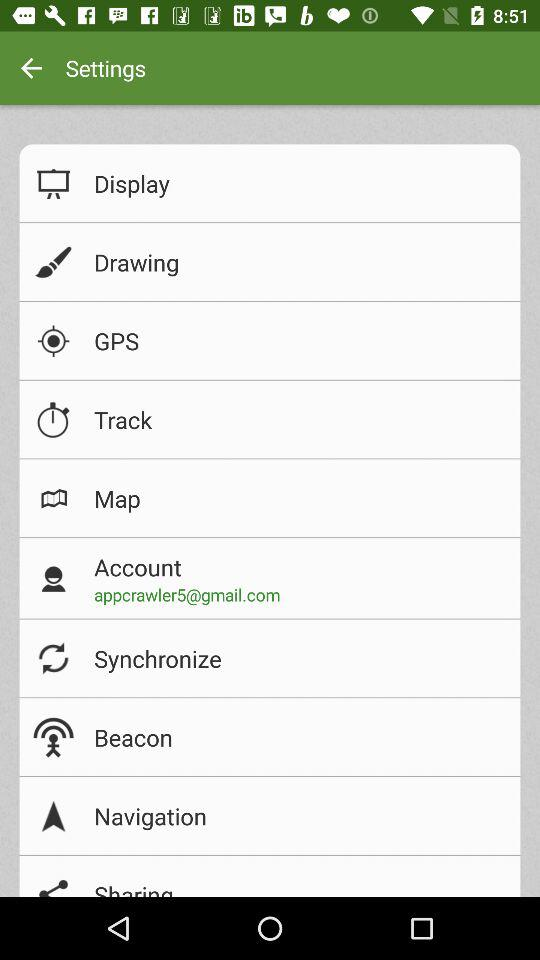Which applications are available for sharing?
When the provided information is insufficient, respond with <no answer>. <no answer> 